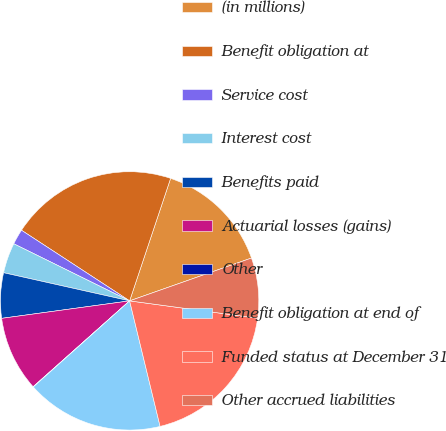<chart> <loc_0><loc_0><loc_500><loc_500><pie_chart><fcel>(in millions)<fcel>Benefit obligation at<fcel>Service cost<fcel>Interest cost<fcel>Benefits paid<fcel>Actuarial losses (gains)<fcel>Other<fcel>Benefit obligation at end of<fcel>Funded status at December 31<fcel>Other accrued liabilities<nl><fcel>14.48%<fcel>20.93%<fcel>1.92%<fcel>3.79%<fcel>5.66%<fcel>9.41%<fcel>0.04%<fcel>17.18%<fcel>19.06%<fcel>7.53%<nl></chart> 